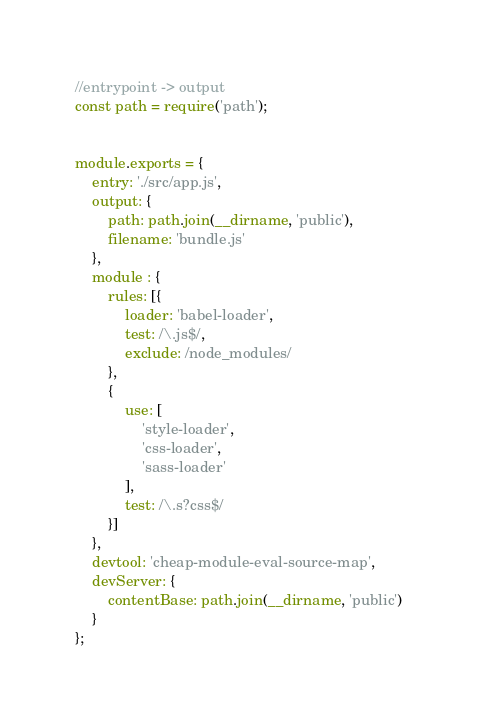<code> <loc_0><loc_0><loc_500><loc_500><_JavaScript_>//entrypoint -> output
const path = require('path');


module.exports = {
    entry: './src/app.js',
    output: {
        path: path.join(__dirname, 'public'),
        filename: 'bundle.js'
    },
    module : {
        rules: [{
            loader: 'babel-loader',
            test: /\.js$/,
            exclude: /node_modules/
        },
        {
            use: [
                'style-loader',
                'css-loader',
                'sass-loader'
            ],
            test: /\.s?css$/
        }]
    },
    devtool: 'cheap-module-eval-source-map',
    devServer: {
        contentBase: path.join(__dirname, 'public')
    }
};</code> 